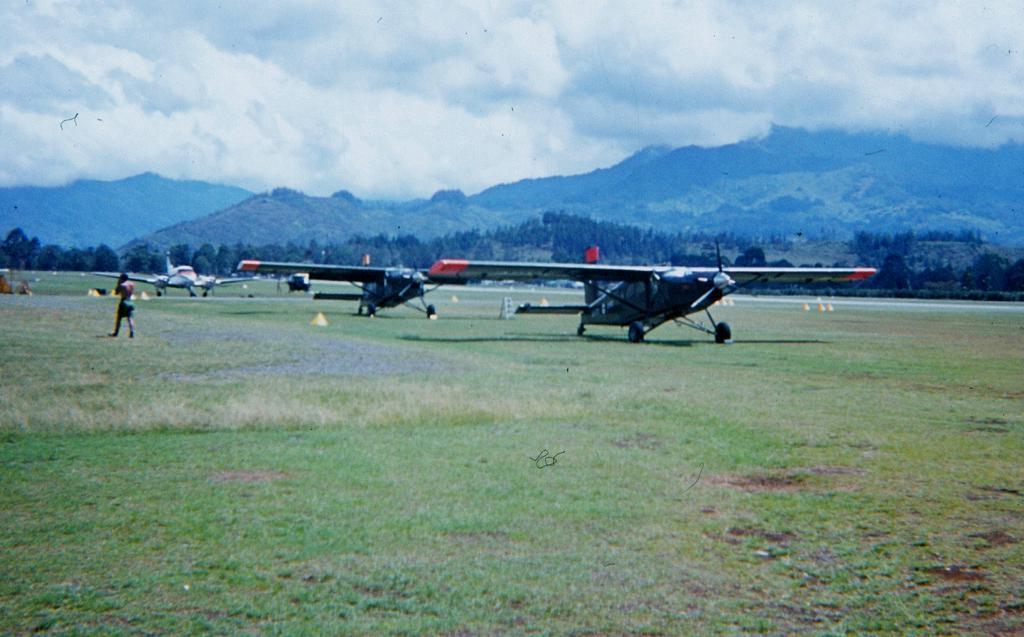Could you give a brief overview of what you see in this image? As we can see in the image there is a man walking and there is grass. There are planes, trees and in the background there are hills. At the top there is sky and clouds. 